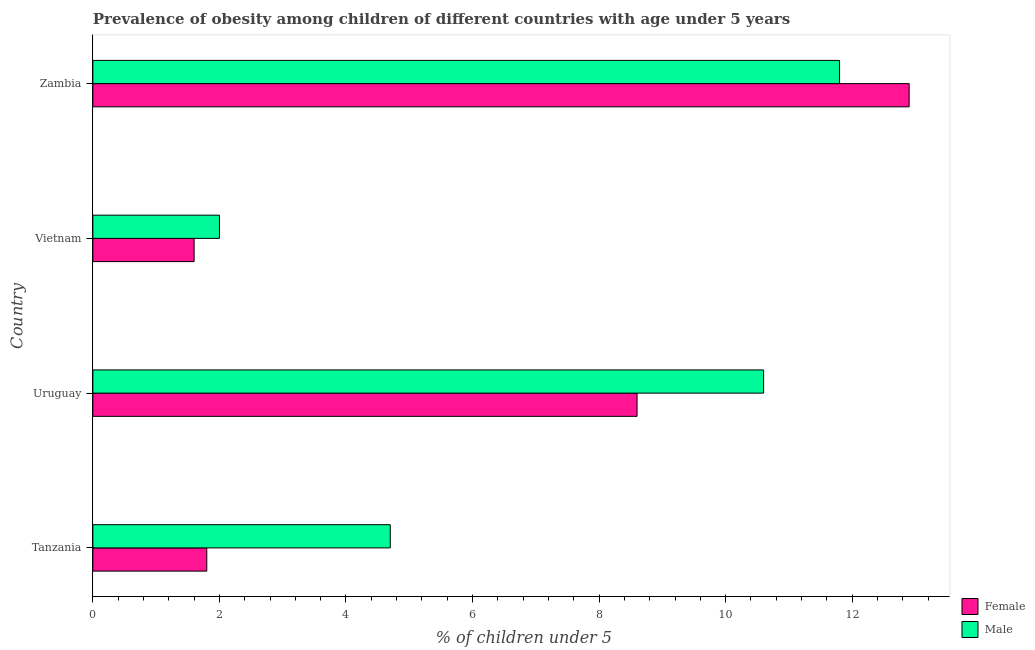How many different coloured bars are there?
Provide a succinct answer. 2. How many groups of bars are there?
Your answer should be compact. 4. Are the number of bars per tick equal to the number of legend labels?
Provide a short and direct response. Yes. How many bars are there on the 2nd tick from the bottom?
Make the answer very short. 2. What is the label of the 1st group of bars from the top?
Your answer should be compact. Zambia. In how many cases, is the number of bars for a given country not equal to the number of legend labels?
Provide a succinct answer. 0. What is the percentage of obese female children in Tanzania?
Ensure brevity in your answer.  1.8. Across all countries, what is the maximum percentage of obese female children?
Provide a succinct answer. 12.9. Across all countries, what is the minimum percentage of obese male children?
Give a very brief answer. 2. In which country was the percentage of obese female children maximum?
Keep it short and to the point. Zambia. In which country was the percentage of obese male children minimum?
Keep it short and to the point. Vietnam. What is the total percentage of obese male children in the graph?
Make the answer very short. 29.1. What is the difference between the percentage of obese female children in Tanzania and that in Zambia?
Your answer should be very brief. -11.1. What is the difference between the percentage of obese male children in Zambia and the percentage of obese female children in Tanzania?
Your answer should be compact. 10. What is the average percentage of obese male children per country?
Your answer should be compact. 7.28. What is the ratio of the percentage of obese female children in Vietnam to that in Zambia?
Ensure brevity in your answer.  0.12. What does the 2nd bar from the bottom in Tanzania represents?
Offer a very short reply. Male. Does the graph contain any zero values?
Your answer should be very brief. No. Where does the legend appear in the graph?
Offer a terse response. Bottom right. How many legend labels are there?
Your answer should be very brief. 2. What is the title of the graph?
Provide a succinct answer. Prevalence of obesity among children of different countries with age under 5 years. Does "IMF concessional" appear as one of the legend labels in the graph?
Offer a very short reply. No. What is the label or title of the X-axis?
Offer a terse response.  % of children under 5. What is the  % of children under 5 in Female in Tanzania?
Your response must be concise. 1.8. What is the  % of children under 5 in Male in Tanzania?
Provide a succinct answer. 4.7. What is the  % of children under 5 in Female in Uruguay?
Make the answer very short. 8.6. What is the  % of children under 5 in Male in Uruguay?
Provide a short and direct response. 10.6. What is the  % of children under 5 in Female in Vietnam?
Your answer should be compact. 1.6. What is the  % of children under 5 in Male in Vietnam?
Provide a short and direct response. 2. What is the  % of children under 5 in Female in Zambia?
Ensure brevity in your answer.  12.9. What is the  % of children under 5 of Male in Zambia?
Ensure brevity in your answer.  11.8. Across all countries, what is the maximum  % of children under 5 in Female?
Provide a succinct answer. 12.9. Across all countries, what is the maximum  % of children under 5 in Male?
Give a very brief answer. 11.8. Across all countries, what is the minimum  % of children under 5 in Female?
Give a very brief answer. 1.6. What is the total  % of children under 5 in Female in the graph?
Give a very brief answer. 24.9. What is the total  % of children under 5 of Male in the graph?
Make the answer very short. 29.1. What is the difference between the  % of children under 5 of Female in Tanzania and that in Uruguay?
Provide a succinct answer. -6.8. What is the difference between the  % of children under 5 of Female in Tanzania and that in Zambia?
Provide a short and direct response. -11.1. What is the difference between the  % of children under 5 of Male in Tanzania and that in Zambia?
Provide a short and direct response. -7.1. What is the difference between the  % of children under 5 of Female in Uruguay and that in Vietnam?
Provide a succinct answer. 7. What is the difference between the  % of children under 5 in Male in Uruguay and that in Vietnam?
Provide a short and direct response. 8.6. What is the difference between the  % of children under 5 of Male in Uruguay and that in Zambia?
Your answer should be compact. -1.2. What is the difference between the  % of children under 5 in Female in Vietnam and that in Zambia?
Provide a succinct answer. -11.3. What is the difference between the  % of children under 5 in Female in Tanzania and the  % of children under 5 in Male in Vietnam?
Give a very brief answer. -0.2. What is the difference between the  % of children under 5 of Female in Uruguay and the  % of children under 5 of Male in Zambia?
Your answer should be very brief. -3.2. What is the average  % of children under 5 in Female per country?
Provide a succinct answer. 6.22. What is the average  % of children under 5 in Male per country?
Provide a succinct answer. 7.28. What is the difference between the  % of children under 5 in Female and  % of children under 5 in Male in Tanzania?
Your response must be concise. -2.9. What is the difference between the  % of children under 5 in Female and  % of children under 5 in Male in Uruguay?
Your answer should be compact. -2. What is the difference between the  % of children under 5 of Female and  % of children under 5 of Male in Vietnam?
Offer a very short reply. -0.4. What is the difference between the  % of children under 5 in Female and  % of children under 5 in Male in Zambia?
Give a very brief answer. 1.1. What is the ratio of the  % of children under 5 of Female in Tanzania to that in Uruguay?
Keep it short and to the point. 0.21. What is the ratio of the  % of children under 5 in Male in Tanzania to that in Uruguay?
Offer a terse response. 0.44. What is the ratio of the  % of children under 5 of Female in Tanzania to that in Vietnam?
Offer a very short reply. 1.12. What is the ratio of the  % of children under 5 of Male in Tanzania to that in Vietnam?
Offer a very short reply. 2.35. What is the ratio of the  % of children under 5 of Female in Tanzania to that in Zambia?
Your answer should be compact. 0.14. What is the ratio of the  % of children under 5 of Male in Tanzania to that in Zambia?
Offer a very short reply. 0.4. What is the ratio of the  % of children under 5 of Female in Uruguay to that in Vietnam?
Ensure brevity in your answer.  5.38. What is the ratio of the  % of children under 5 of Male in Uruguay to that in Vietnam?
Your response must be concise. 5.3. What is the ratio of the  % of children under 5 in Female in Uruguay to that in Zambia?
Your answer should be very brief. 0.67. What is the ratio of the  % of children under 5 of Male in Uruguay to that in Zambia?
Offer a terse response. 0.9. What is the ratio of the  % of children under 5 in Female in Vietnam to that in Zambia?
Your answer should be compact. 0.12. What is the ratio of the  % of children under 5 of Male in Vietnam to that in Zambia?
Offer a very short reply. 0.17. What is the difference between the highest and the second highest  % of children under 5 in Female?
Keep it short and to the point. 4.3. What is the difference between the highest and the second highest  % of children under 5 in Male?
Ensure brevity in your answer.  1.2. 